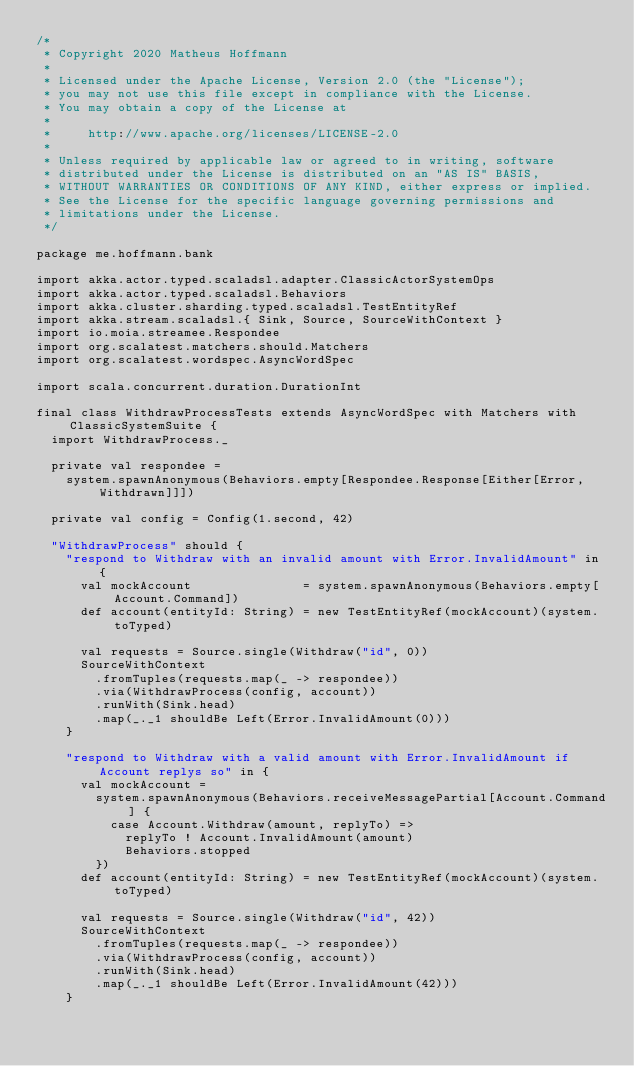Convert code to text. <code><loc_0><loc_0><loc_500><loc_500><_Scala_>/*
 * Copyright 2020 Matheus Hoffmann
 *
 * Licensed under the Apache License, Version 2.0 (the "License");
 * you may not use this file except in compliance with the License.
 * You may obtain a copy of the License at
 *
 *     http://www.apache.org/licenses/LICENSE-2.0
 *
 * Unless required by applicable law or agreed to in writing, software
 * distributed under the License is distributed on an "AS IS" BASIS,
 * WITHOUT WARRANTIES OR CONDITIONS OF ANY KIND, either express or implied.
 * See the License for the specific language governing permissions and
 * limitations under the License.
 */

package me.hoffmann.bank

import akka.actor.typed.scaladsl.adapter.ClassicActorSystemOps
import akka.actor.typed.scaladsl.Behaviors
import akka.cluster.sharding.typed.scaladsl.TestEntityRef
import akka.stream.scaladsl.{ Sink, Source, SourceWithContext }
import io.moia.streamee.Respondee
import org.scalatest.matchers.should.Matchers
import org.scalatest.wordspec.AsyncWordSpec

import scala.concurrent.duration.DurationInt

final class WithdrawProcessTests extends AsyncWordSpec with Matchers with ClassicSystemSuite {
  import WithdrawProcess._

  private val respondee =
    system.spawnAnonymous(Behaviors.empty[Respondee.Response[Either[Error, Withdrawn]]])

  private val config = Config(1.second, 42)

  "WithdrawProcess" should {
    "respond to Withdraw with an invalid amount with Error.InvalidAmount" in {
      val mockAccount               = system.spawnAnonymous(Behaviors.empty[Account.Command])
      def account(entityId: String) = new TestEntityRef(mockAccount)(system.toTyped)

      val requests = Source.single(Withdraw("id", 0))
      SourceWithContext
        .fromTuples(requests.map(_ -> respondee))
        .via(WithdrawProcess(config, account))
        .runWith(Sink.head)
        .map(_._1 shouldBe Left(Error.InvalidAmount(0)))
    }

    "respond to Withdraw with a valid amount with Error.InvalidAmount if Account replys so" in {
      val mockAccount =
        system.spawnAnonymous(Behaviors.receiveMessagePartial[Account.Command] {
          case Account.Withdraw(amount, replyTo) =>
            replyTo ! Account.InvalidAmount(amount)
            Behaviors.stopped
        })
      def account(entityId: String) = new TestEntityRef(mockAccount)(system.toTyped)

      val requests = Source.single(Withdraw("id", 42))
      SourceWithContext
        .fromTuples(requests.map(_ -> respondee))
        .via(WithdrawProcess(config, account))
        .runWith(Sink.head)
        .map(_._1 shouldBe Left(Error.InvalidAmount(42)))
    }
</code> 